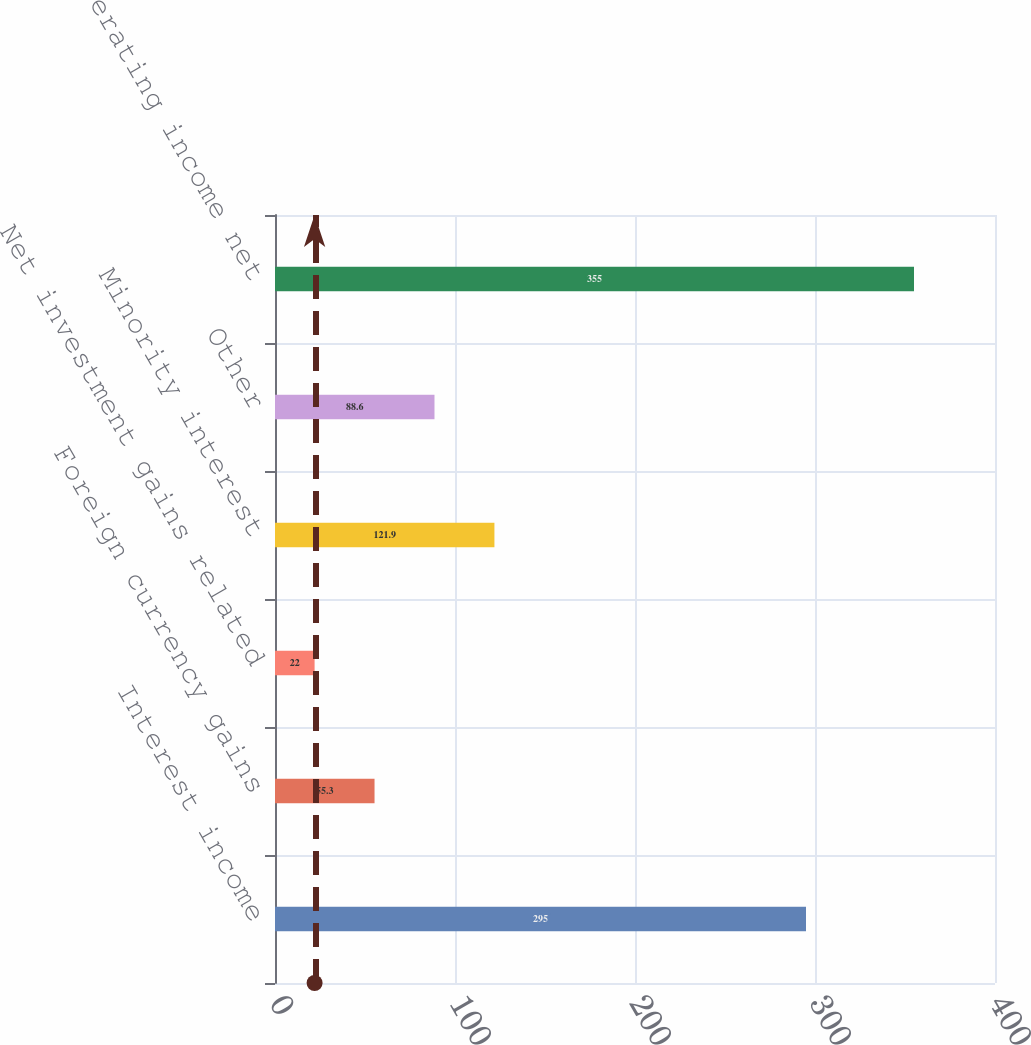<chart> <loc_0><loc_0><loc_500><loc_500><bar_chart><fcel>Interest income<fcel>Foreign currency gains<fcel>Net investment gains related<fcel>Minority interest<fcel>Other<fcel>Total non-operating income net<nl><fcel>295<fcel>55.3<fcel>22<fcel>121.9<fcel>88.6<fcel>355<nl></chart> 